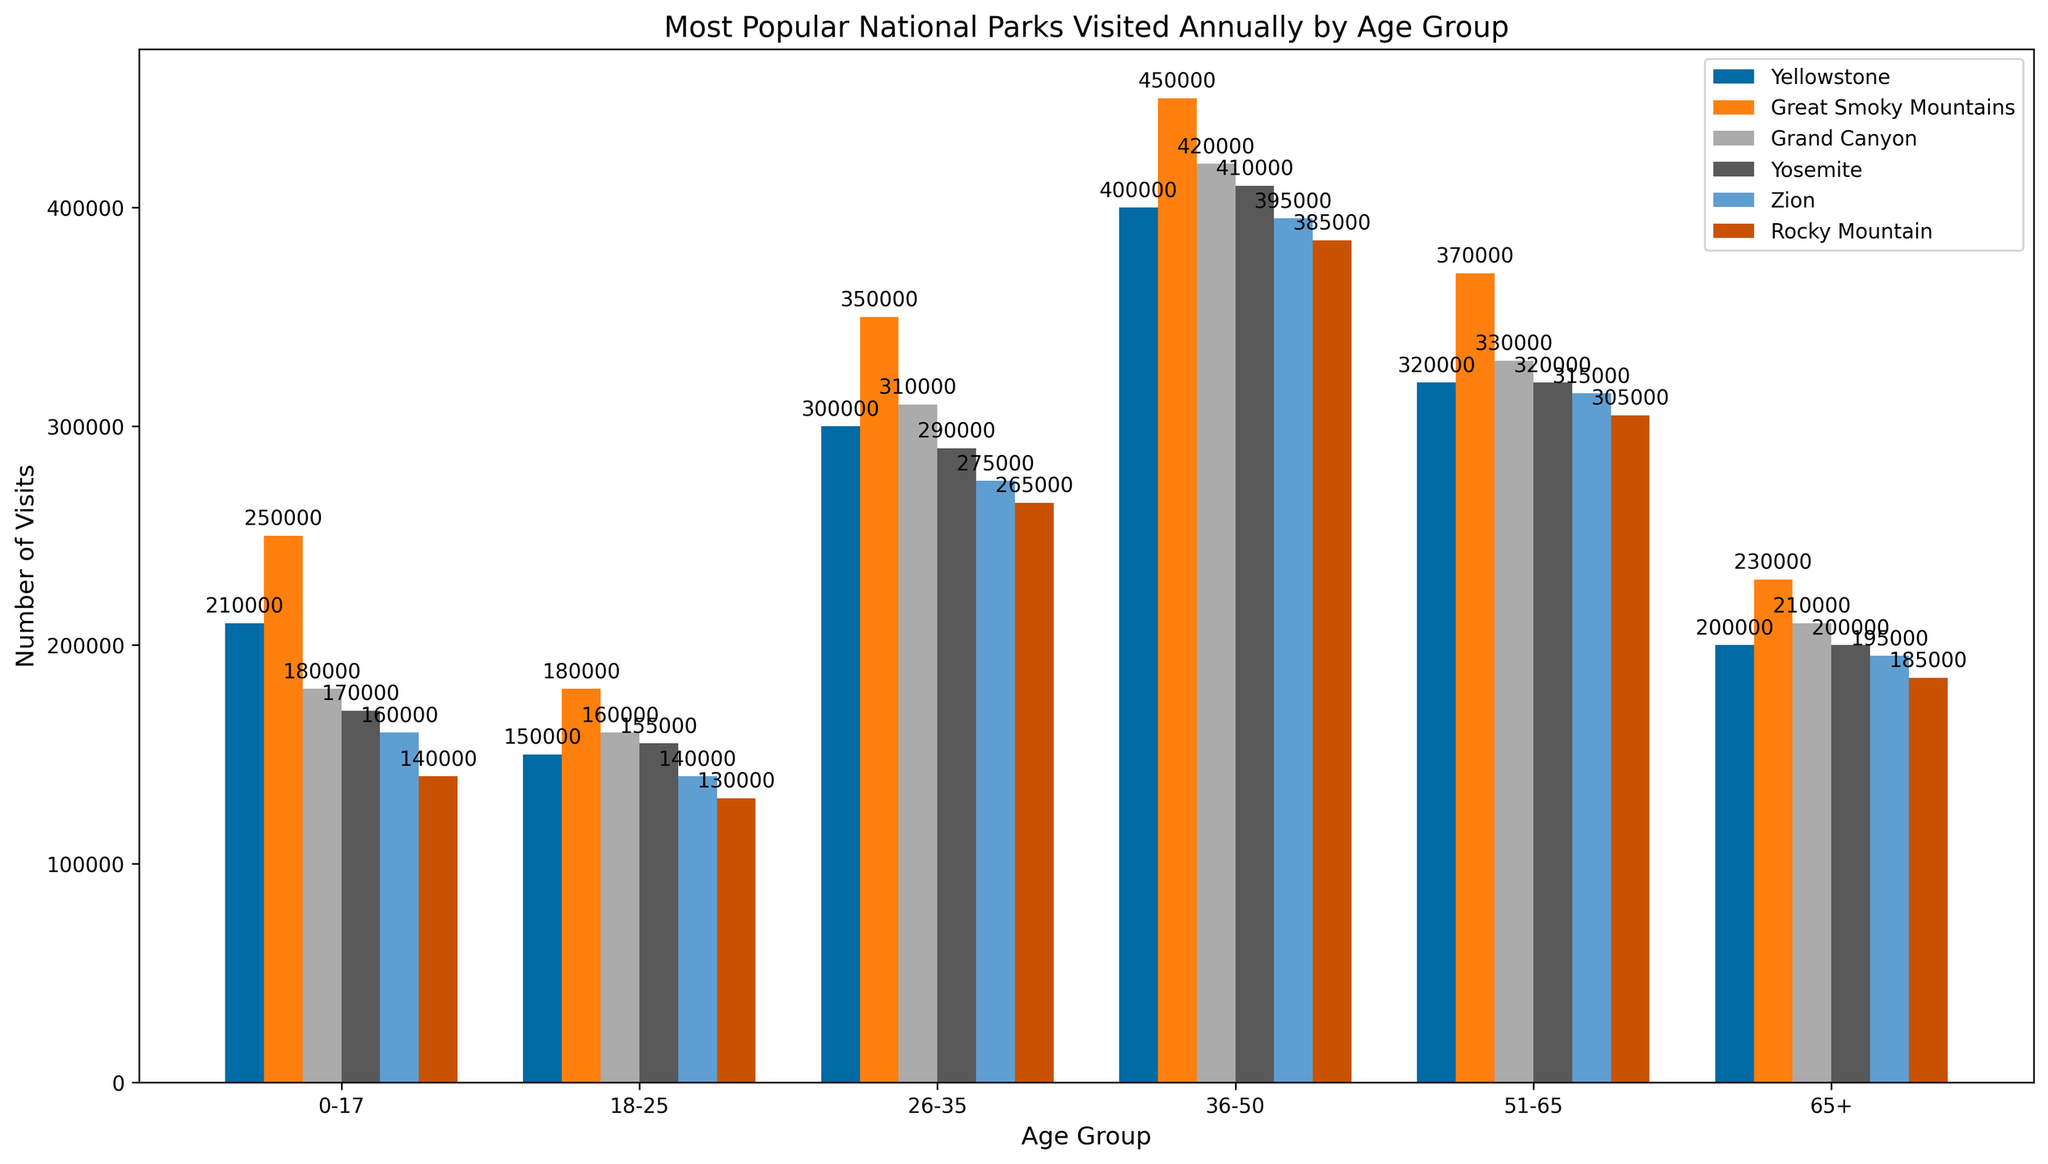Which age group visited the Great Smoky Mountains the most? Looking at the height of the bars for the Great Smoky Mountains, the age group 36-50 has the highest bar.
Answer: 36-50 What is the total number of visits to Zion by age groups 18-25 and 26-35? For age group 18-25, Zion has 140,000 visits. For age group 26-35, Zion has 275,000 visits. Summing these gives 140,000 + 275,000 = 415,000 visits.
Answer: 415,000 Which national park had the least visits by the 0-17 age group? The smallest bar for the 0-17 age group is for the Rocky Mountain park with 140,000 visits.
Answer: Rocky Mountain What is the average number of visits to Yosemite for all age groups? The visits to Yosemite are 170,000 (0-17), 155,000 (18-25), 290,000 (26-35), 410,000 (36-50), 320,000 (51-65), and 200,000 (65+). Summing these gives 170,000 + 155,000 + 290,000 + 410,000 + 320,000 + 200,000 = 1,545,000. Dividing by the number of groups (6) gives 1,545,000 / 6 = 257,500 visits.
Answer: 257,500 How many more visits did the Grand Canyon receive from the 36-50 age group compared to the 51-65 age group? For the 36-50 age group, the Grand Canyon has 420,000 visits, and for the 51-65 age group, it has 330,000 visits. The difference is 420,000 - 330,000 = 90,000 visits.
Answer: 90,000 